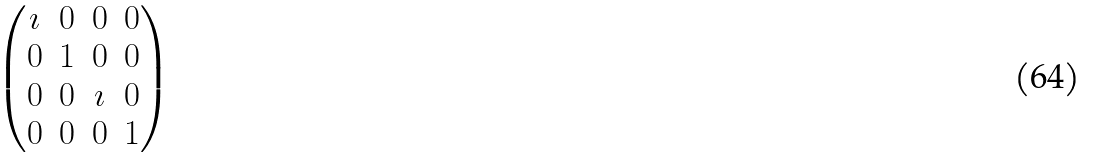<formula> <loc_0><loc_0><loc_500><loc_500>\begin{pmatrix} \imath & 0 & 0 & 0 \\ 0 & 1 & 0 & 0 \\ 0 & 0 & \imath & 0 \\ 0 & 0 & 0 & 1 \end{pmatrix}</formula> 